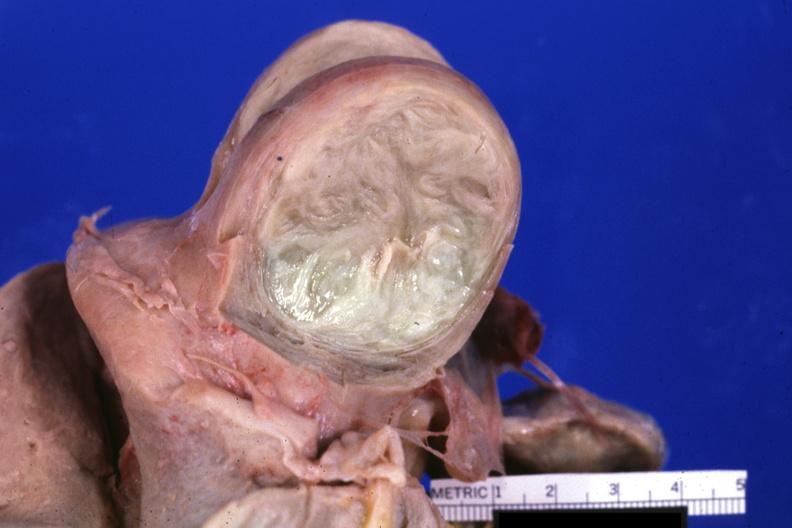what is present?
Answer the question using a single word or phrase. Uterus 